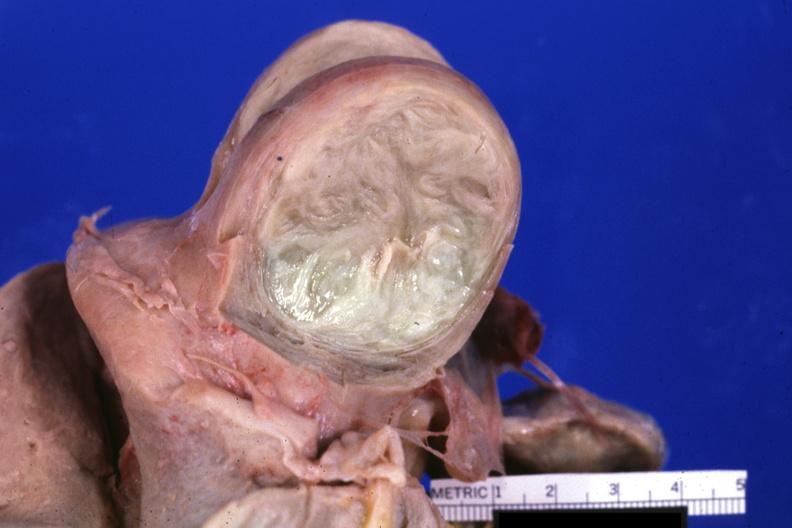what is present?
Answer the question using a single word or phrase. Uterus 